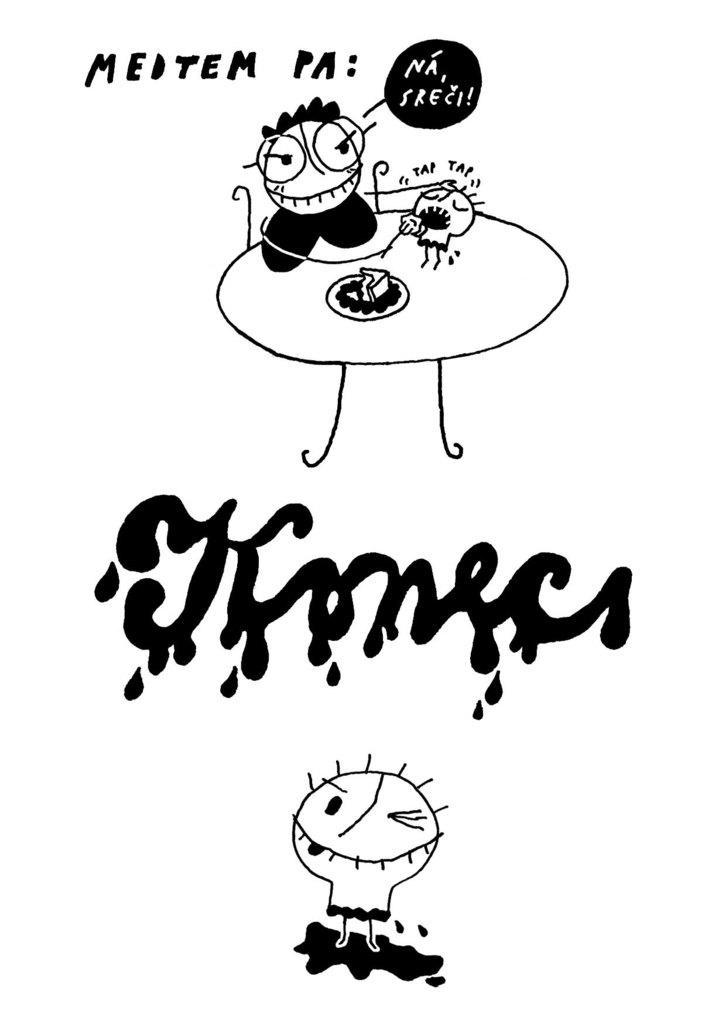Can you describe this image briefly? In the image I can see some images of cartoon and some edited text. 